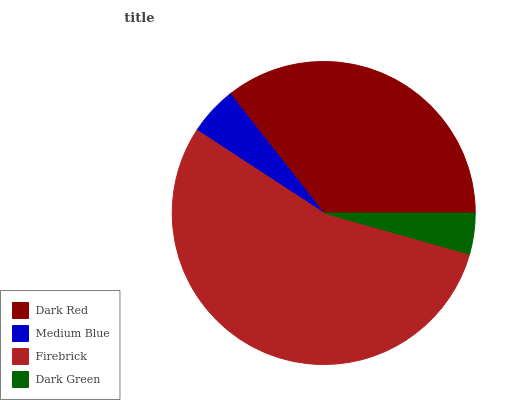Is Dark Green the minimum?
Answer yes or no. Yes. Is Firebrick the maximum?
Answer yes or no. Yes. Is Medium Blue the minimum?
Answer yes or no. No. Is Medium Blue the maximum?
Answer yes or no. No. Is Dark Red greater than Medium Blue?
Answer yes or no. Yes. Is Medium Blue less than Dark Red?
Answer yes or no. Yes. Is Medium Blue greater than Dark Red?
Answer yes or no. No. Is Dark Red less than Medium Blue?
Answer yes or no. No. Is Dark Red the high median?
Answer yes or no. Yes. Is Medium Blue the low median?
Answer yes or no. Yes. Is Firebrick the high median?
Answer yes or no. No. Is Dark Green the low median?
Answer yes or no. No. 